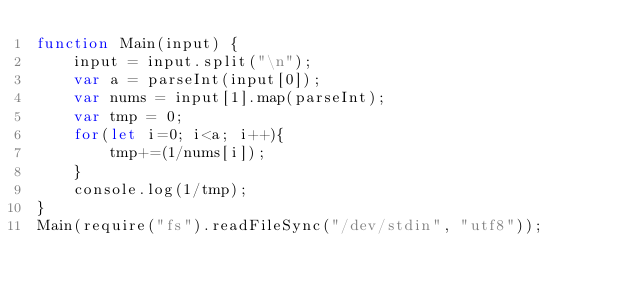<code> <loc_0><loc_0><loc_500><loc_500><_JavaScript_>function Main(input) {
    input = input.split("\n");
    var a = parseInt(input[0]);
    var nums = input[1].map(parseInt);
    var tmp = 0;
    for(let i=0; i<a; i++){
        tmp+=(1/nums[i]);
    }
    console.log(1/tmp);
}
Main(require("fs").readFileSync("/dev/stdin", "utf8"));
</code> 